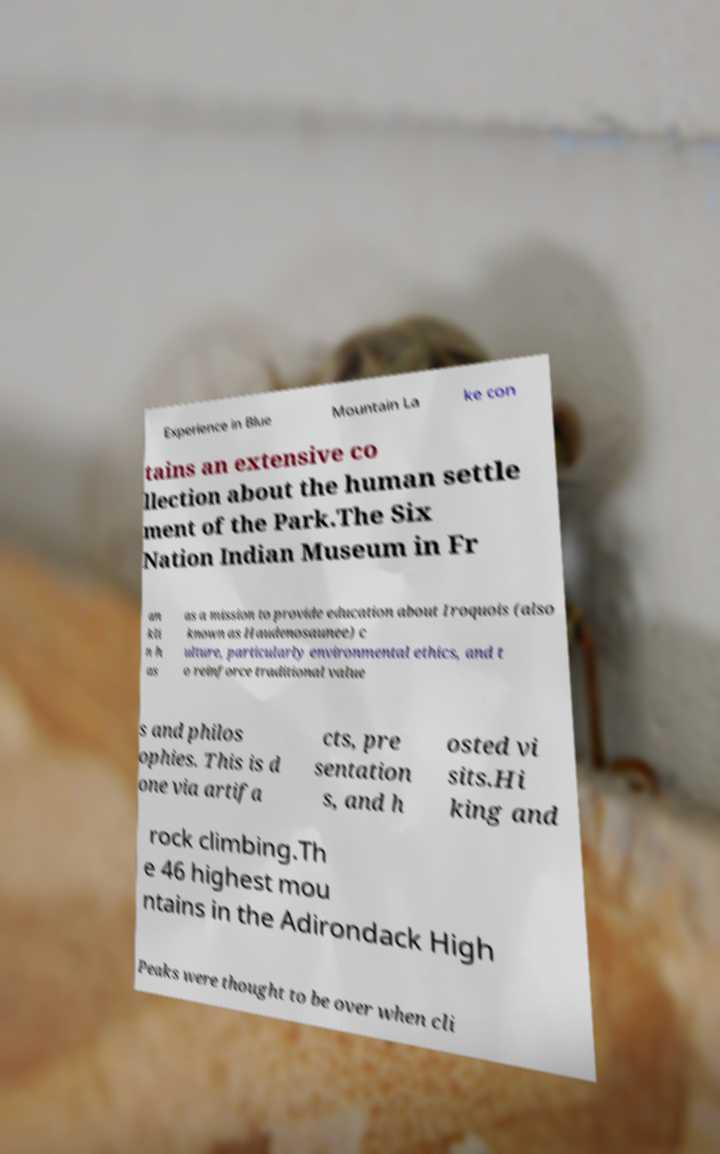Can you read and provide the text displayed in the image?This photo seems to have some interesting text. Can you extract and type it out for me? Experience in Blue Mountain La ke con tains an extensive co llection about the human settle ment of the Park.The Six Nation Indian Museum in Fr an kli n h as as a mission to provide education about Iroquois (also known as Haudenosaunee) c ulture, particularly environmental ethics, and t o reinforce traditional value s and philos ophies. This is d one via artifa cts, pre sentation s, and h osted vi sits.Hi king and rock climbing.Th e 46 highest mou ntains in the Adirondack High Peaks were thought to be over when cli 